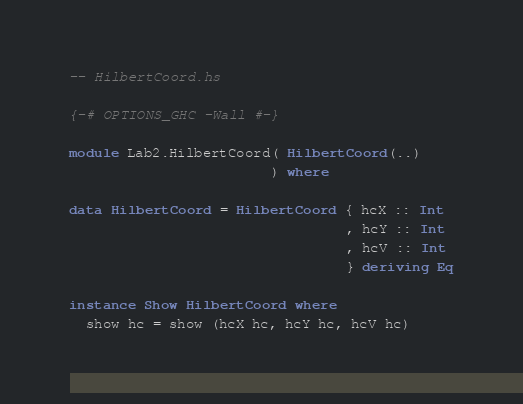<code> <loc_0><loc_0><loc_500><loc_500><_Haskell_>-- HilbertCoord.hs

{-# OPTIONS_GHC -Wall #-}

module Lab2.HilbertCoord( HilbertCoord(..)
                        ) where

data HilbertCoord = HilbertCoord { hcX :: Int
                                 , hcY :: Int
                                 , hcV :: Int
                                 } deriving Eq

instance Show HilbertCoord where
  show hc = show (hcX hc, hcY hc, hcV hc)
</code> 